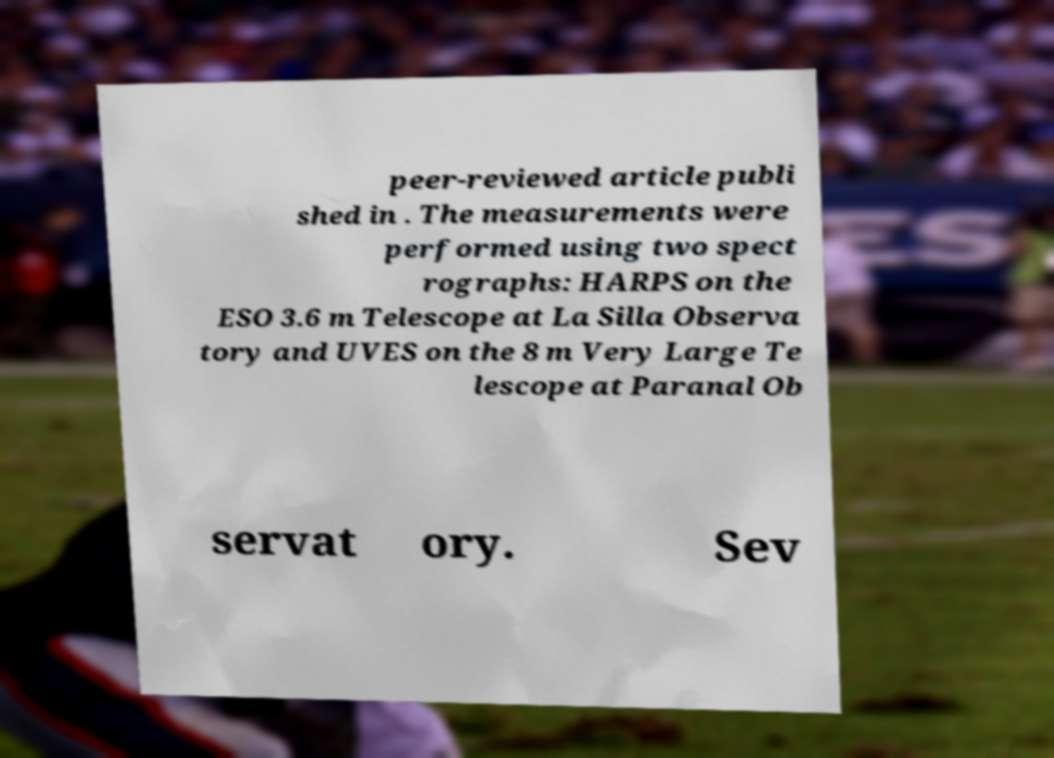Please identify and transcribe the text found in this image. peer-reviewed article publi shed in . The measurements were performed using two spect rographs: HARPS on the ESO 3.6 m Telescope at La Silla Observa tory and UVES on the 8 m Very Large Te lescope at Paranal Ob servat ory. Sev 